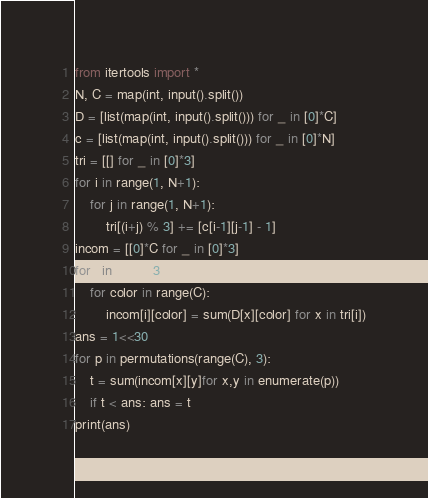<code> <loc_0><loc_0><loc_500><loc_500><_Python_>from itertools import *
N, C = map(int, input().split())
D = [list(map(int, input().split())) for _ in [0]*C]
c = [list(map(int, input().split())) for _ in [0]*N]
tri = [[] for _ in [0]*3]
for i in range(1, N+1):
    for j in range(1, N+1):
        tri[(i+j) % 3] += [c[i-1][j-1] - 1]
incom = [[0]*C for _ in [0]*3]
for i in range(3):
    for color in range(C):
        incom[i][color] = sum(D[x][color] for x in tri[i])
ans = 1<<30
for p in permutations(range(C), 3):
    t = sum(incom[x][y]for x,y in enumerate(p))
    if t < ans: ans = t
print(ans)</code> 